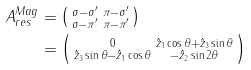<formula> <loc_0><loc_0><loc_500><loc_500>A _ { r e s } ^ { M a g } & = \left ( \begin{smallmatrix} \sigma - \sigma ^ { \prime } & \pi - \sigma ^ { \prime } \\ \sigma - \pi ^ { \prime } & \pi - \pi ^ { \prime } \end{smallmatrix} \right ) \\ & = \left ( \begin{smallmatrix} 0 & \hat { z } _ { 1 } \cos \theta + \hat { z } _ { 3 } \sin \theta \\ \hat { z } _ { 3 } \sin \theta - \hat { z } _ { 1 } \cos \theta & - \hat { z } _ { 2 } \sin 2 \theta \end{smallmatrix} \right )</formula> 